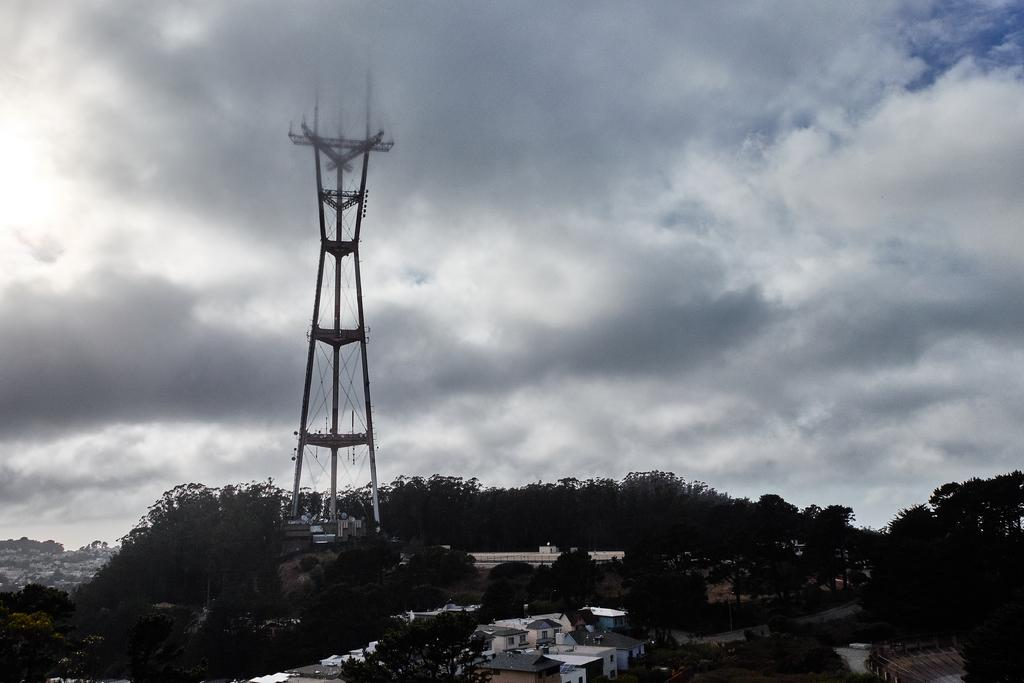What type of structures can be seen in the image? There are houses in the image. What other natural elements are present in the image? There are trees in the image. What specific architectural feature can be seen in the image? There is a tower in the image. What is visible in the background of the image? The sky is visible in the background of the image. What can be observed in the sky? Clouds are present in the sky. Where are the children playing in the image? There are no children present in the image. What type of crate is visible in the image? There is no crate present in the image. 